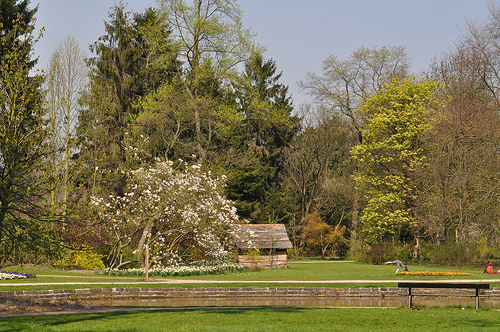<image>
Is the flower tree behind the tree? No. The flower tree is not behind the tree. From this viewpoint, the flower tree appears to be positioned elsewhere in the scene. 